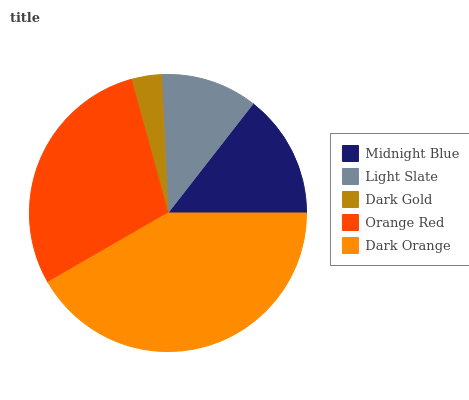Is Dark Gold the minimum?
Answer yes or no. Yes. Is Dark Orange the maximum?
Answer yes or no. Yes. Is Light Slate the minimum?
Answer yes or no. No. Is Light Slate the maximum?
Answer yes or no. No. Is Midnight Blue greater than Light Slate?
Answer yes or no. Yes. Is Light Slate less than Midnight Blue?
Answer yes or no. Yes. Is Light Slate greater than Midnight Blue?
Answer yes or no. No. Is Midnight Blue less than Light Slate?
Answer yes or no. No. Is Midnight Blue the high median?
Answer yes or no. Yes. Is Midnight Blue the low median?
Answer yes or no. Yes. Is Light Slate the high median?
Answer yes or no. No. Is Orange Red the low median?
Answer yes or no. No. 